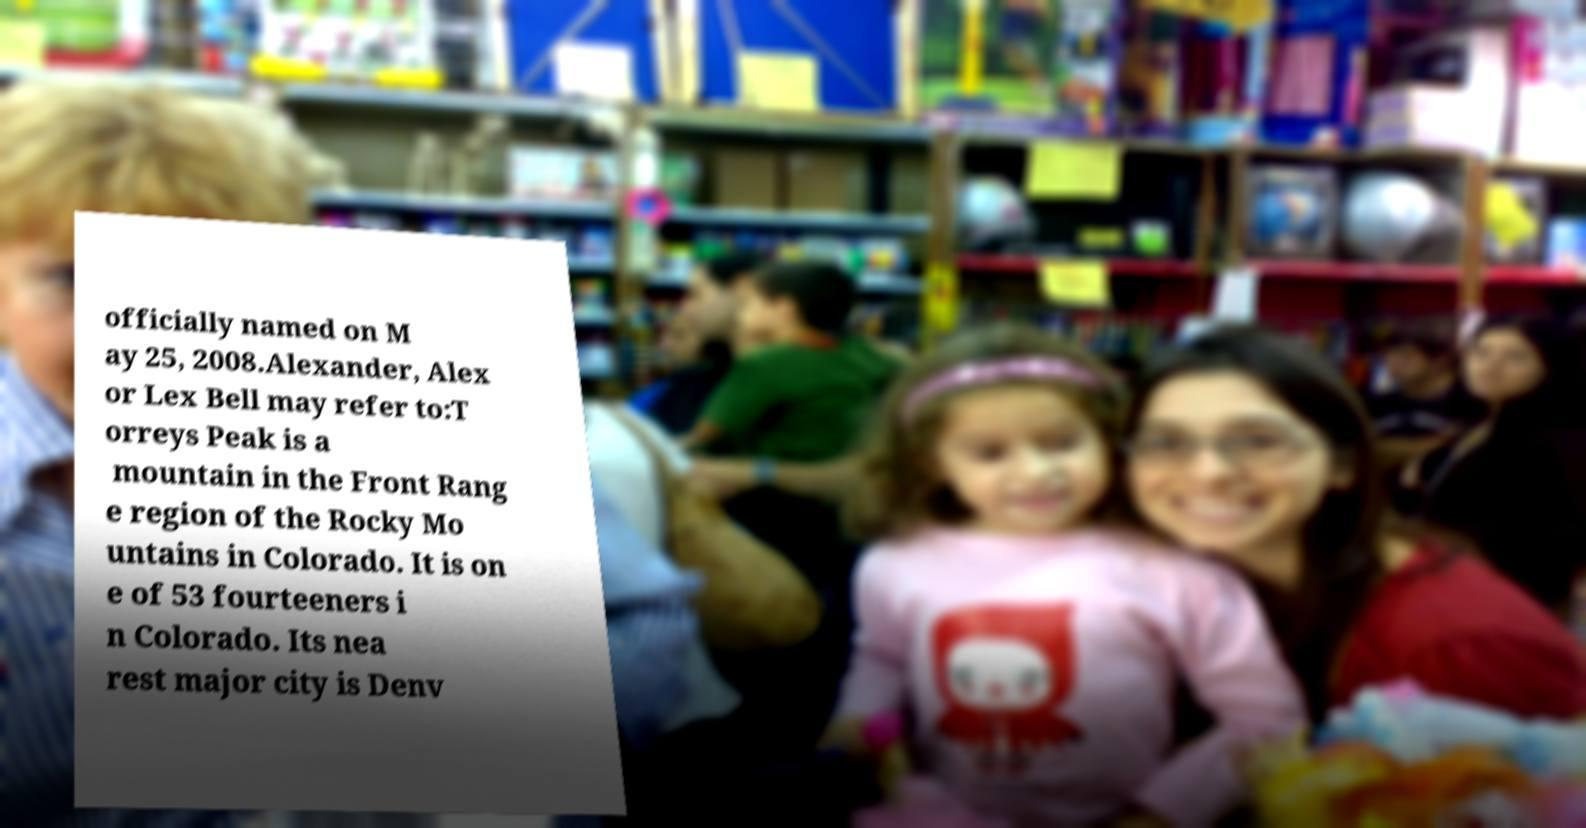There's text embedded in this image that I need extracted. Can you transcribe it verbatim? officially named on M ay 25, 2008.Alexander, Alex or Lex Bell may refer to:T orreys Peak is a mountain in the Front Rang e region of the Rocky Mo untains in Colorado. It is on e of 53 fourteeners i n Colorado. Its nea rest major city is Denv 